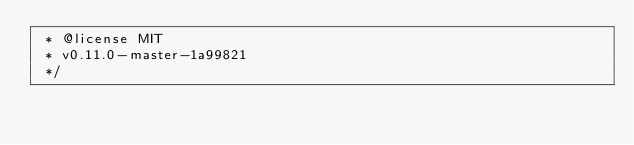<code> <loc_0><loc_0><loc_500><loc_500><_JavaScript_> * @license MIT
 * v0.11.0-master-1a99821
 */</code> 